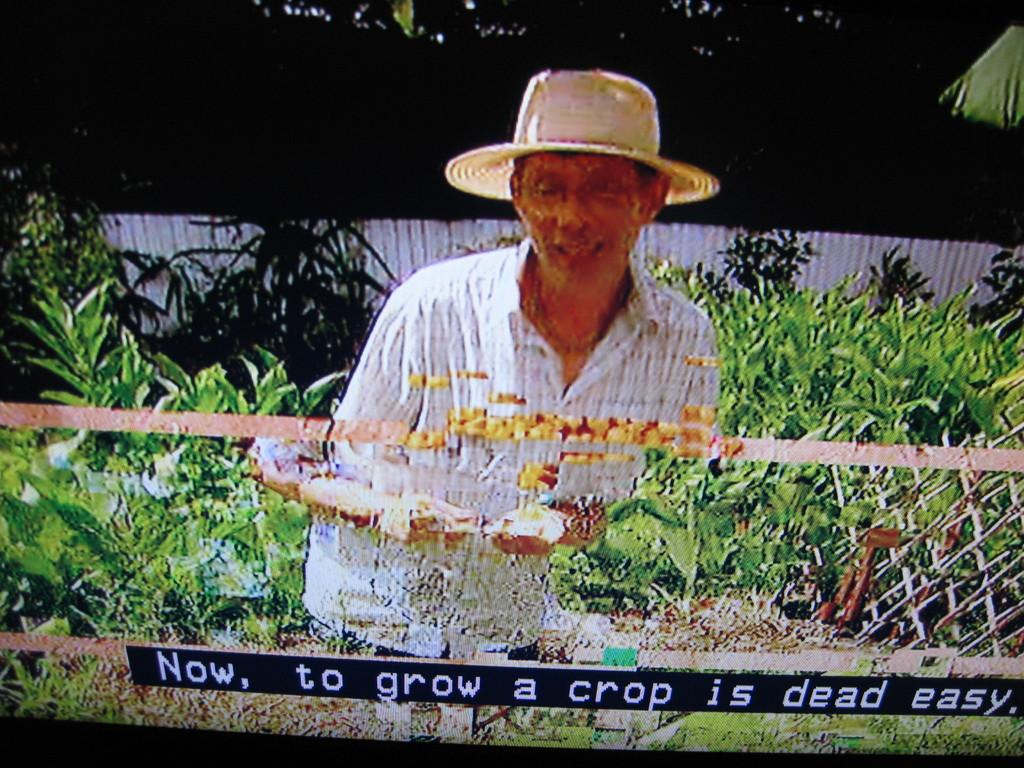What is the main object in the image? There is a screen in the image. What can be seen on the screen? The screen displays a man wearing a hat, plants, a wall, and some text. What is the color of the background on the screen? The background of the screen is dark. Where is the bed located in the image? There is no bed present in the image; it only features a screen with various elements displayed on it. What type of box can be seen on the screen? There is no box visible on the screen; it displays a man wearing a hat, plants, a wall, and some text. 